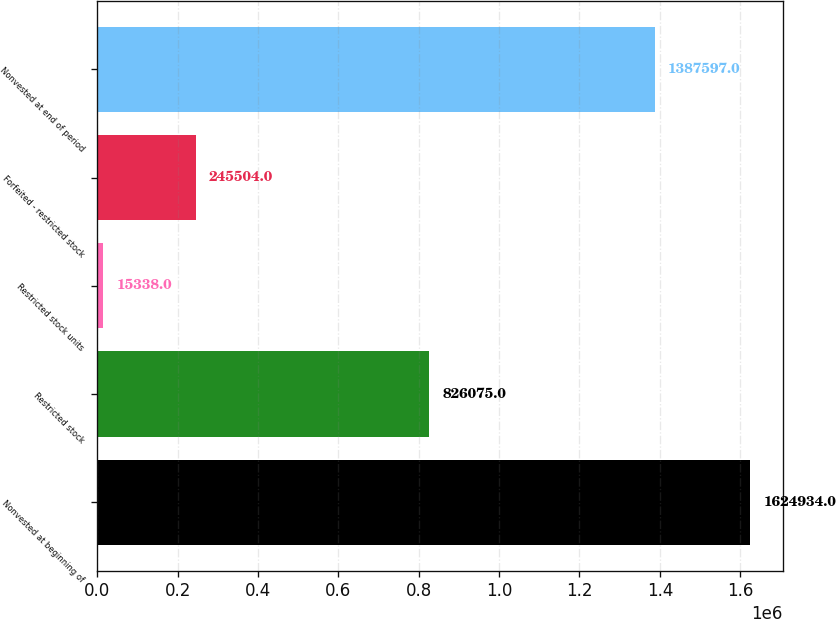<chart> <loc_0><loc_0><loc_500><loc_500><bar_chart><fcel>Nonvested at beginning of<fcel>Restricted stock<fcel>Restricted stock units<fcel>Forfeited - restricted stock<fcel>Nonvested at end of period<nl><fcel>1.62493e+06<fcel>826075<fcel>15338<fcel>245504<fcel>1.3876e+06<nl></chart> 